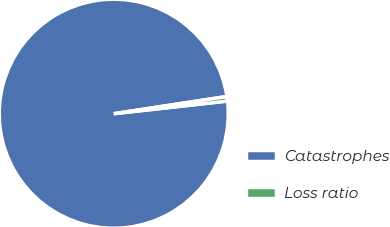Convert chart to OTSL. <chart><loc_0><loc_0><loc_500><loc_500><pie_chart><fcel>Catastrophes<fcel>Loss ratio<nl><fcel>99.36%<fcel>0.64%<nl></chart> 